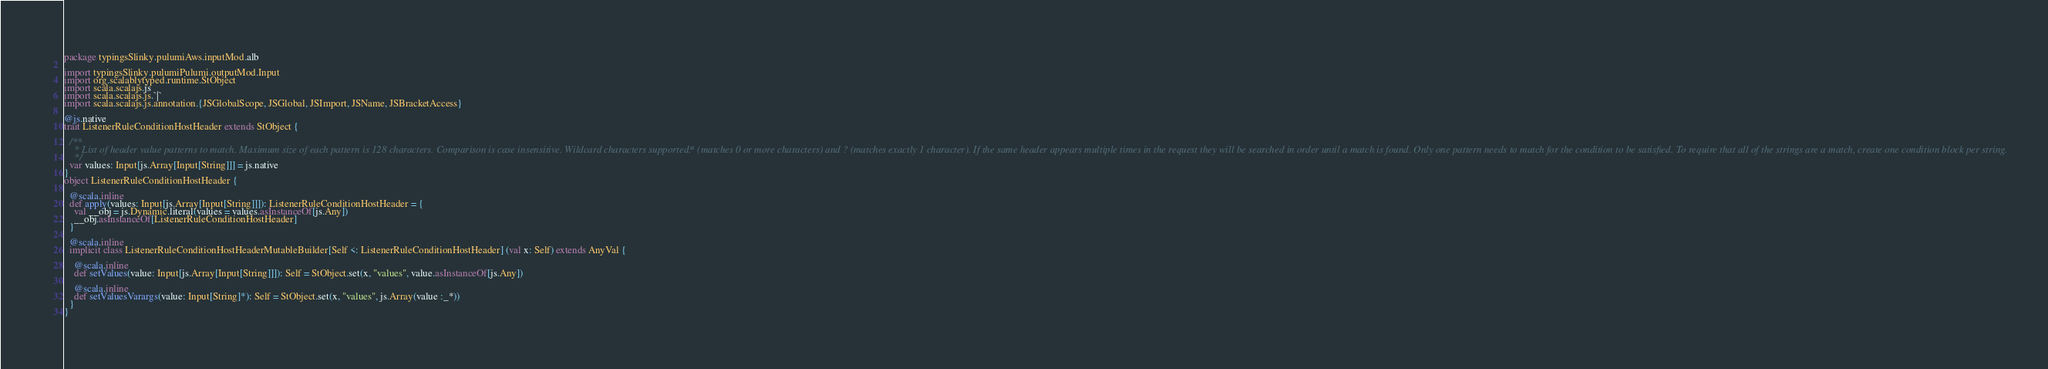<code> <loc_0><loc_0><loc_500><loc_500><_Scala_>package typingsSlinky.pulumiAws.inputMod.alb

import typingsSlinky.pulumiPulumi.outputMod.Input
import org.scalablytyped.runtime.StObject
import scala.scalajs.js
import scala.scalajs.js.`|`
import scala.scalajs.js.annotation.{JSGlobalScope, JSGlobal, JSImport, JSName, JSBracketAccess}

@js.native
trait ListenerRuleConditionHostHeader extends StObject {
  
  /**
    * List of header value patterns to match. Maximum size of each pattern is 128 characters. Comparison is case insensitive. Wildcard characters supported: * (matches 0 or more characters) and ? (matches exactly 1 character). If the same header appears multiple times in the request they will be searched in order until a match is found. Only one pattern needs to match for the condition to be satisfied. To require that all of the strings are a match, create one condition block per string.
    */
  var values: Input[js.Array[Input[String]]] = js.native
}
object ListenerRuleConditionHostHeader {
  
  @scala.inline
  def apply(values: Input[js.Array[Input[String]]]): ListenerRuleConditionHostHeader = {
    val __obj = js.Dynamic.literal(values = values.asInstanceOf[js.Any])
    __obj.asInstanceOf[ListenerRuleConditionHostHeader]
  }
  
  @scala.inline
  implicit class ListenerRuleConditionHostHeaderMutableBuilder[Self <: ListenerRuleConditionHostHeader] (val x: Self) extends AnyVal {
    
    @scala.inline
    def setValues(value: Input[js.Array[Input[String]]]): Self = StObject.set(x, "values", value.asInstanceOf[js.Any])
    
    @scala.inline
    def setValuesVarargs(value: Input[String]*): Self = StObject.set(x, "values", js.Array(value :_*))
  }
}
</code> 